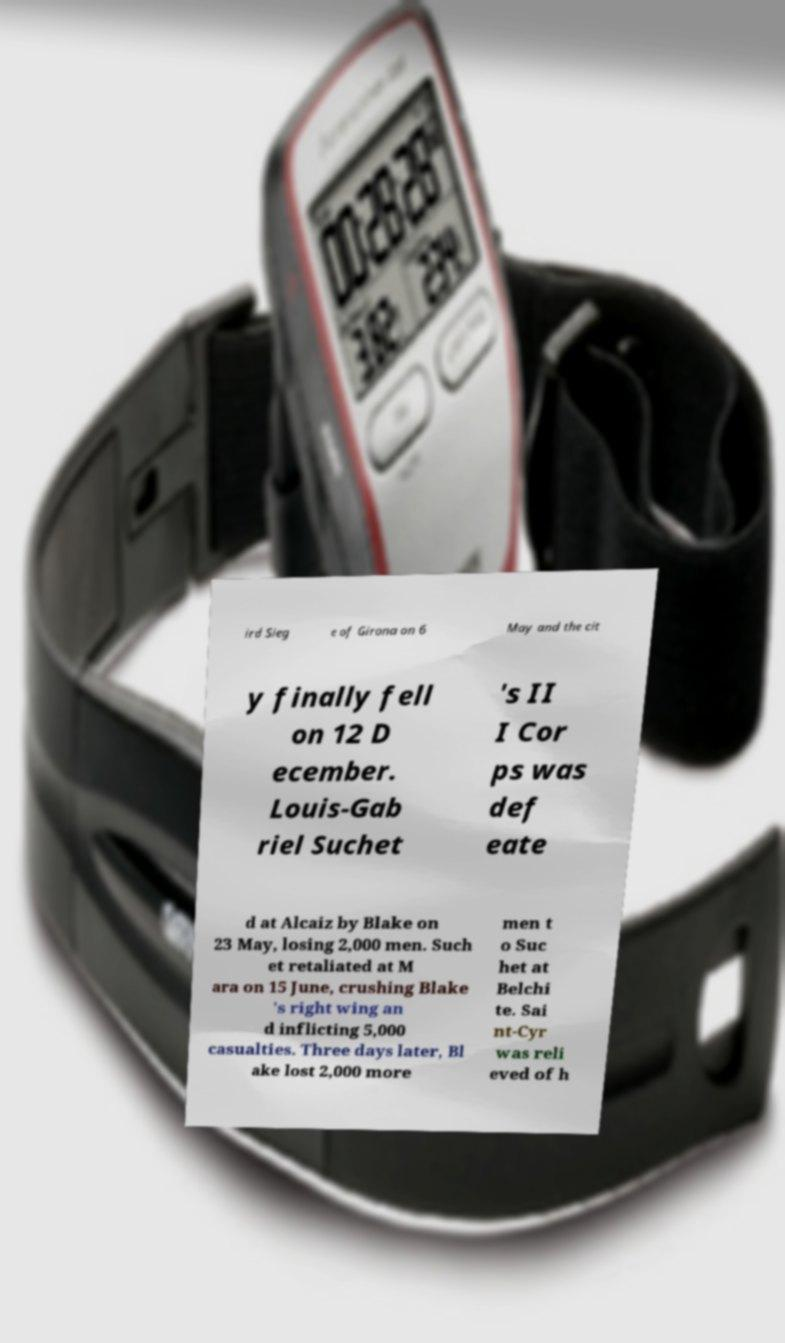Please read and relay the text visible in this image. What does it say? ird Sieg e of Girona on 6 May and the cit y finally fell on 12 D ecember. Louis-Gab riel Suchet 's II I Cor ps was def eate d at Alcaiz by Blake on 23 May, losing 2,000 men. Such et retaliated at M ara on 15 June, crushing Blake 's right wing an d inflicting 5,000 casualties. Three days later, Bl ake lost 2,000 more men t o Suc het at Belchi te. Sai nt-Cyr was reli eved of h 